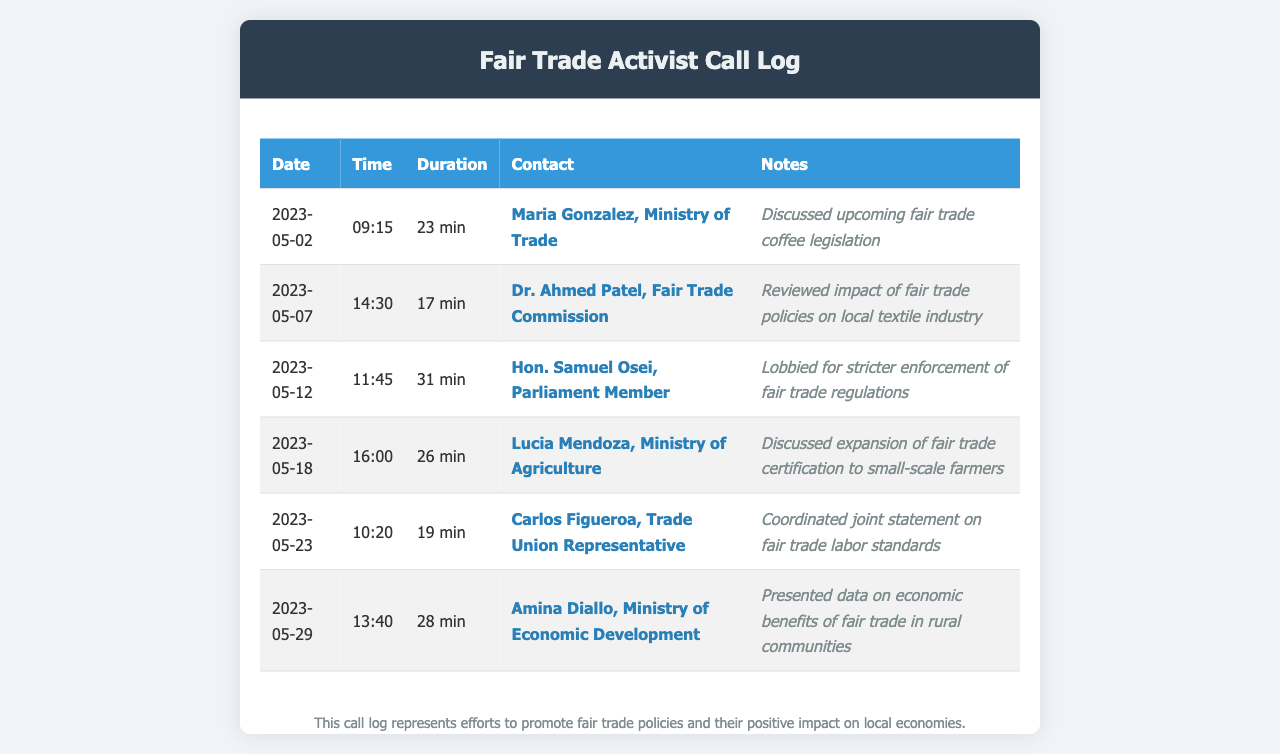What is the date of the first call? The date of the first call recorded in the log is listed in the first row of the table, which is 2023-05-02.
Answer: 2023-05-02 Who did the activist speak with on May 12? The activist spoke with Hon. Samuel Osei on May 12, as indicated in the corresponding row of the table.
Answer: Hon. Samuel Osei How long was the call with Amina Diallo? The duration of the call with Amina Diallo is stated directly in the document, which is 28 minutes.
Answer: 28 min What topic was discussed in the call with Maria Gonzalez? The topic discussed is outlined in the notes for the call with Maria Gonzalez, which is upcoming fair trade coffee legislation.
Answer: upcoming fair trade coffee legislation How many calls are listed in total? The total number of calls is given by counting the rows in the table, which shows six entries.
Answer: 6 Which government official discussed the expansion of fair trade certification? The individual who discussed the expansion of fair trade certification is given in the notes for the call with Lucia Mendoza.
Answer: Lucia Mendoza What was the main concern during the call with Dr. Ahmed Patel? The main concern during the call with Dr. Ahmed Patel is captured in the notes, which mention the impact of fair trade policies on the local textile industry.
Answer: impact of fair trade policies on local textile industry Which call had the longest duration? The call with the longest duration is found by comparing the duration of each call, with Hon. Samuel Osei's call lasting 31 minutes.
Answer: 31 min 